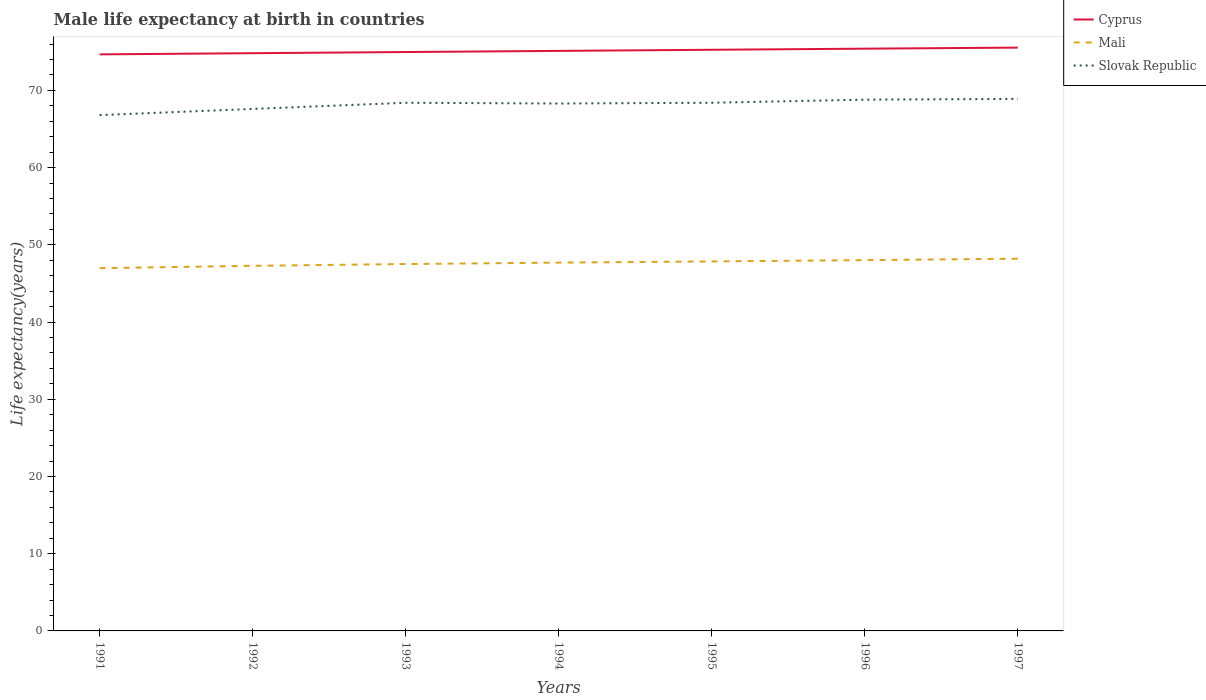Is the number of lines equal to the number of legend labels?
Provide a succinct answer. Yes. Across all years, what is the maximum male life expectancy at birth in Slovak Republic?
Your answer should be very brief. 66.8. What is the total male life expectancy at birth in Cyprus in the graph?
Ensure brevity in your answer.  -0.58. What is the difference between the highest and the lowest male life expectancy at birth in Slovak Republic?
Give a very brief answer. 5. Is the male life expectancy at birth in Slovak Republic strictly greater than the male life expectancy at birth in Mali over the years?
Offer a very short reply. No. How many lines are there?
Your answer should be very brief. 3. What is the difference between two consecutive major ticks on the Y-axis?
Your response must be concise. 10. Does the graph contain any zero values?
Ensure brevity in your answer.  No. Does the graph contain grids?
Give a very brief answer. No. How many legend labels are there?
Ensure brevity in your answer.  3. What is the title of the graph?
Give a very brief answer. Male life expectancy at birth in countries. What is the label or title of the Y-axis?
Provide a short and direct response. Life expectancy(years). What is the Life expectancy(years) in Cyprus in 1991?
Your answer should be compact. 74.67. What is the Life expectancy(years) in Mali in 1991?
Make the answer very short. 46.98. What is the Life expectancy(years) in Slovak Republic in 1991?
Ensure brevity in your answer.  66.8. What is the Life expectancy(years) of Cyprus in 1992?
Your answer should be very brief. 74.82. What is the Life expectancy(years) in Mali in 1992?
Offer a very short reply. 47.28. What is the Life expectancy(years) in Slovak Republic in 1992?
Make the answer very short. 67.6. What is the Life expectancy(years) in Cyprus in 1993?
Offer a very short reply. 74.97. What is the Life expectancy(years) in Mali in 1993?
Your response must be concise. 47.51. What is the Life expectancy(years) of Slovak Republic in 1993?
Your answer should be very brief. 68.4. What is the Life expectancy(years) of Cyprus in 1994?
Make the answer very short. 75.12. What is the Life expectancy(years) in Mali in 1994?
Provide a succinct answer. 47.7. What is the Life expectancy(years) of Slovak Republic in 1994?
Provide a short and direct response. 68.3. What is the Life expectancy(years) in Cyprus in 1995?
Your answer should be compact. 75.26. What is the Life expectancy(years) in Mali in 1995?
Your response must be concise. 47.85. What is the Life expectancy(years) of Slovak Republic in 1995?
Give a very brief answer. 68.4. What is the Life expectancy(years) in Cyprus in 1996?
Provide a short and direct response. 75.4. What is the Life expectancy(years) of Mali in 1996?
Provide a succinct answer. 48.02. What is the Life expectancy(years) in Slovak Republic in 1996?
Offer a very short reply. 68.8. What is the Life expectancy(years) of Cyprus in 1997?
Your response must be concise. 75.54. What is the Life expectancy(years) of Mali in 1997?
Your answer should be compact. 48.2. What is the Life expectancy(years) in Slovak Republic in 1997?
Your response must be concise. 68.9. Across all years, what is the maximum Life expectancy(years) of Cyprus?
Offer a terse response. 75.54. Across all years, what is the maximum Life expectancy(years) in Mali?
Your answer should be very brief. 48.2. Across all years, what is the maximum Life expectancy(years) of Slovak Republic?
Make the answer very short. 68.9. Across all years, what is the minimum Life expectancy(years) in Cyprus?
Ensure brevity in your answer.  74.67. Across all years, what is the minimum Life expectancy(years) in Mali?
Keep it short and to the point. 46.98. Across all years, what is the minimum Life expectancy(years) of Slovak Republic?
Provide a short and direct response. 66.8. What is the total Life expectancy(years) in Cyprus in the graph?
Give a very brief answer. 525.78. What is the total Life expectancy(years) of Mali in the graph?
Ensure brevity in your answer.  333.54. What is the total Life expectancy(years) in Slovak Republic in the graph?
Make the answer very short. 477.2. What is the difference between the Life expectancy(years) in Cyprus in 1991 and that in 1992?
Offer a very short reply. -0.15. What is the difference between the Life expectancy(years) in Mali in 1991 and that in 1992?
Offer a very short reply. -0.3. What is the difference between the Life expectancy(years) in Slovak Republic in 1991 and that in 1992?
Ensure brevity in your answer.  -0.8. What is the difference between the Life expectancy(years) of Cyprus in 1991 and that in 1993?
Make the answer very short. -0.3. What is the difference between the Life expectancy(years) of Mali in 1991 and that in 1993?
Offer a terse response. -0.54. What is the difference between the Life expectancy(years) of Cyprus in 1991 and that in 1994?
Keep it short and to the point. -0.45. What is the difference between the Life expectancy(years) in Mali in 1991 and that in 1994?
Provide a short and direct response. -0.72. What is the difference between the Life expectancy(years) of Cyprus in 1991 and that in 1995?
Your answer should be very brief. -0.59. What is the difference between the Life expectancy(years) of Mali in 1991 and that in 1995?
Ensure brevity in your answer.  -0.88. What is the difference between the Life expectancy(years) in Slovak Republic in 1991 and that in 1995?
Your answer should be very brief. -1.6. What is the difference between the Life expectancy(years) of Cyprus in 1991 and that in 1996?
Make the answer very short. -0.74. What is the difference between the Life expectancy(years) of Mali in 1991 and that in 1996?
Provide a succinct answer. -1.04. What is the difference between the Life expectancy(years) of Slovak Republic in 1991 and that in 1996?
Provide a short and direct response. -2. What is the difference between the Life expectancy(years) in Cyprus in 1991 and that in 1997?
Offer a terse response. -0.88. What is the difference between the Life expectancy(years) of Mali in 1991 and that in 1997?
Your answer should be compact. -1.23. What is the difference between the Life expectancy(years) of Slovak Republic in 1991 and that in 1997?
Provide a short and direct response. -2.1. What is the difference between the Life expectancy(years) of Cyprus in 1992 and that in 1993?
Keep it short and to the point. -0.15. What is the difference between the Life expectancy(years) of Mali in 1992 and that in 1993?
Make the answer very short. -0.23. What is the difference between the Life expectancy(years) in Slovak Republic in 1992 and that in 1993?
Offer a very short reply. -0.8. What is the difference between the Life expectancy(years) in Cyprus in 1992 and that in 1994?
Give a very brief answer. -0.3. What is the difference between the Life expectancy(years) of Mali in 1992 and that in 1994?
Make the answer very short. -0.41. What is the difference between the Life expectancy(years) of Slovak Republic in 1992 and that in 1994?
Make the answer very short. -0.7. What is the difference between the Life expectancy(years) of Cyprus in 1992 and that in 1995?
Provide a short and direct response. -0.44. What is the difference between the Life expectancy(years) of Mali in 1992 and that in 1995?
Your answer should be compact. -0.57. What is the difference between the Life expectancy(years) of Cyprus in 1992 and that in 1996?
Give a very brief answer. -0.58. What is the difference between the Life expectancy(years) of Mali in 1992 and that in 1996?
Your answer should be compact. -0.73. What is the difference between the Life expectancy(years) of Slovak Republic in 1992 and that in 1996?
Your response must be concise. -1.2. What is the difference between the Life expectancy(years) of Cyprus in 1992 and that in 1997?
Offer a terse response. -0.72. What is the difference between the Life expectancy(years) in Mali in 1992 and that in 1997?
Offer a terse response. -0.92. What is the difference between the Life expectancy(years) of Cyprus in 1993 and that in 1994?
Your answer should be compact. -0.15. What is the difference between the Life expectancy(years) of Mali in 1993 and that in 1994?
Give a very brief answer. -0.18. What is the difference between the Life expectancy(years) in Cyprus in 1993 and that in 1995?
Offer a very short reply. -0.29. What is the difference between the Life expectancy(years) in Mali in 1993 and that in 1995?
Your answer should be compact. -0.34. What is the difference between the Life expectancy(years) in Cyprus in 1993 and that in 1996?
Your response must be concise. -0.43. What is the difference between the Life expectancy(years) of Mali in 1993 and that in 1996?
Your answer should be compact. -0.5. What is the difference between the Life expectancy(years) of Slovak Republic in 1993 and that in 1996?
Your response must be concise. -0.4. What is the difference between the Life expectancy(years) of Cyprus in 1993 and that in 1997?
Ensure brevity in your answer.  -0.57. What is the difference between the Life expectancy(years) in Mali in 1993 and that in 1997?
Offer a terse response. -0.69. What is the difference between the Life expectancy(years) of Slovak Republic in 1993 and that in 1997?
Keep it short and to the point. -0.5. What is the difference between the Life expectancy(years) of Cyprus in 1994 and that in 1995?
Ensure brevity in your answer.  -0.14. What is the difference between the Life expectancy(years) in Mali in 1994 and that in 1995?
Give a very brief answer. -0.16. What is the difference between the Life expectancy(years) of Slovak Republic in 1994 and that in 1995?
Your answer should be very brief. -0.1. What is the difference between the Life expectancy(years) in Cyprus in 1994 and that in 1996?
Provide a short and direct response. -0.29. What is the difference between the Life expectancy(years) in Mali in 1994 and that in 1996?
Ensure brevity in your answer.  -0.32. What is the difference between the Life expectancy(years) of Cyprus in 1994 and that in 1997?
Your answer should be compact. -0.43. What is the difference between the Life expectancy(years) in Mali in 1994 and that in 1997?
Give a very brief answer. -0.51. What is the difference between the Life expectancy(years) in Slovak Republic in 1994 and that in 1997?
Keep it short and to the point. -0.6. What is the difference between the Life expectancy(years) of Cyprus in 1995 and that in 1996?
Offer a terse response. -0.14. What is the difference between the Life expectancy(years) in Mali in 1995 and that in 1996?
Make the answer very short. -0.16. What is the difference between the Life expectancy(years) of Slovak Republic in 1995 and that in 1996?
Offer a terse response. -0.4. What is the difference between the Life expectancy(years) of Cyprus in 1995 and that in 1997?
Provide a short and direct response. -0.28. What is the difference between the Life expectancy(years) of Mali in 1995 and that in 1997?
Provide a succinct answer. -0.35. What is the difference between the Life expectancy(years) in Slovak Republic in 1995 and that in 1997?
Provide a succinct answer. -0.5. What is the difference between the Life expectancy(years) of Cyprus in 1996 and that in 1997?
Your answer should be very brief. -0.14. What is the difference between the Life expectancy(years) in Mali in 1996 and that in 1997?
Offer a terse response. -0.19. What is the difference between the Life expectancy(years) in Cyprus in 1991 and the Life expectancy(years) in Mali in 1992?
Offer a very short reply. 27.39. What is the difference between the Life expectancy(years) of Cyprus in 1991 and the Life expectancy(years) of Slovak Republic in 1992?
Give a very brief answer. 7.07. What is the difference between the Life expectancy(years) of Mali in 1991 and the Life expectancy(years) of Slovak Republic in 1992?
Give a very brief answer. -20.62. What is the difference between the Life expectancy(years) in Cyprus in 1991 and the Life expectancy(years) in Mali in 1993?
Provide a short and direct response. 27.15. What is the difference between the Life expectancy(years) of Cyprus in 1991 and the Life expectancy(years) of Slovak Republic in 1993?
Offer a very short reply. 6.27. What is the difference between the Life expectancy(years) in Mali in 1991 and the Life expectancy(years) in Slovak Republic in 1993?
Offer a terse response. -21.42. What is the difference between the Life expectancy(years) of Cyprus in 1991 and the Life expectancy(years) of Mali in 1994?
Offer a very short reply. 26.97. What is the difference between the Life expectancy(years) in Cyprus in 1991 and the Life expectancy(years) in Slovak Republic in 1994?
Give a very brief answer. 6.37. What is the difference between the Life expectancy(years) in Mali in 1991 and the Life expectancy(years) in Slovak Republic in 1994?
Provide a short and direct response. -21.32. What is the difference between the Life expectancy(years) in Cyprus in 1991 and the Life expectancy(years) in Mali in 1995?
Ensure brevity in your answer.  26.81. What is the difference between the Life expectancy(years) in Cyprus in 1991 and the Life expectancy(years) in Slovak Republic in 1995?
Give a very brief answer. 6.27. What is the difference between the Life expectancy(years) of Mali in 1991 and the Life expectancy(years) of Slovak Republic in 1995?
Give a very brief answer. -21.42. What is the difference between the Life expectancy(years) in Cyprus in 1991 and the Life expectancy(years) in Mali in 1996?
Ensure brevity in your answer.  26.65. What is the difference between the Life expectancy(years) of Cyprus in 1991 and the Life expectancy(years) of Slovak Republic in 1996?
Provide a succinct answer. 5.87. What is the difference between the Life expectancy(years) of Mali in 1991 and the Life expectancy(years) of Slovak Republic in 1996?
Keep it short and to the point. -21.82. What is the difference between the Life expectancy(years) in Cyprus in 1991 and the Life expectancy(years) in Mali in 1997?
Provide a short and direct response. 26.46. What is the difference between the Life expectancy(years) in Cyprus in 1991 and the Life expectancy(years) in Slovak Republic in 1997?
Provide a short and direct response. 5.77. What is the difference between the Life expectancy(years) of Mali in 1991 and the Life expectancy(years) of Slovak Republic in 1997?
Your answer should be very brief. -21.92. What is the difference between the Life expectancy(years) in Cyprus in 1992 and the Life expectancy(years) in Mali in 1993?
Your response must be concise. 27.3. What is the difference between the Life expectancy(years) in Cyprus in 1992 and the Life expectancy(years) in Slovak Republic in 1993?
Provide a succinct answer. 6.42. What is the difference between the Life expectancy(years) of Mali in 1992 and the Life expectancy(years) of Slovak Republic in 1993?
Keep it short and to the point. -21.12. What is the difference between the Life expectancy(years) in Cyprus in 1992 and the Life expectancy(years) in Mali in 1994?
Offer a very short reply. 27.12. What is the difference between the Life expectancy(years) in Cyprus in 1992 and the Life expectancy(years) in Slovak Republic in 1994?
Give a very brief answer. 6.52. What is the difference between the Life expectancy(years) of Mali in 1992 and the Life expectancy(years) of Slovak Republic in 1994?
Your answer should be very brief. -21.02. What is the difference between the Life expectancy(years) of Cyprus in 1992 and the Life expectancy(years) of Mali in 1995?
Your answer should be compact. 26.96. What is the difference between the Life expectancy(years) of Cyprus in 1992 and the Life expectancy(years) of Slovak Republic in 1995?
Your answer should be compact. 6.42. What is the difference between the Life expectancy(years) of Mali in 1992 and the Life expectancy(years) of Slovak Republic in 1995?
Provide a short and direct response. -21.12. What is the difference between the Life expectancy(years) in Cyprus in 1992 and the Life expectancy(years) in Mali in 1996?
Provide a short and direct response. 26.8. What is the difference between the Life expectancy(years) in Cyprus in 1992 and the Life expectancy(years) in Slovak Republic in 1996?
Your answer should be very brief. 6.02. What is the difference between the Life expectancy(years) of Mali in 1992 and the Life expectancy(years) of Slovak Republic in 1996?
Your answer should be compact. -21.52. What is the difference between the Life expectancy(years) of Cyprus in 1992 and the Life expectancy(years) of Mali in 1997?
Make the answer very short. 26.61. What is the difference between the Life expectancy(years) in Cyprus in 1992 and the Life expectancy(years) in Slovak Republic in 1997?
Your response must be concise. 5.92. What is the difference between the Life expectancy(years) in Mali in 1992 and the Life expectancy(years) in Slovak Republic in 1997?
Your answer should be very brief. -21.62. What is the difference between the Life expectancy(years) of Cyprus in 1993 and the Life expectancy(years) of Mali in 1994?
Ensure brevity in your answer.  27.27. What is the difference between the Life expectancy(years) of Cyprus in 1993 and the Life expectancy(years) of Slovak Republic in 1994?
Offer a very short reply. 6.67. What is the difference between the Life expectancy(years) of Mali in 1993 and the Life expectancy(years) of Slovak Republic in 1994?
Provide a succinct answer. -20.79. What is the difference between the Life expectancy(years) in Cyprus in 1993 and the Life expectancy(years) in Mali in 1995?
Your answer should be very brief. 27.11. What is the difference between the Life expectancy(years) in Cyprus in 1993 and the Life expectancy(years) in Slovak Republic in 1995?
Your answer should be very brief. 6.57. What is the difference between the Life expectancy(years) in Mali in 1993 and the Life expectancy(years) in Slovak Republic in 1995?
Make the answer very short. -20.89. What is the difference between the Life expectancy(years) of Cyprus in 1993 and the Life expectancy(years) of Mali in 1996?
Your response must be concise. 26.95. What is the difference between the Life expectancy(years) of Cyprus in 1993 and the Life expectancy(years) of Slovak Republic in 1996?
Provide a short and direct response. 6.17. What is the difference between the Life expectancy(years) of Mali in 1993 and the Life expectancy(years) of Slovak Republic in 1996?
Ensure brevity in your answer.  -21.29. What is the difference between the Life expectancy(years) in Cyprus in 1993 and the Life expectancy(years) in Mali in 1997?
Your answer should be very brief. 26.76. What is the difference between the Life expectancy(years) of Cyprus in 1993 and the Life expectancy(years) of Slovak Republic in 1997?
Provide a short and direct response. 6.07. What is the difference between the Life expectancy(years) of Mali in 1993 and the Life expectancy(years) of Slovak Republic in 1997?
Make the answer very short. -21.39. What is the difference between the Life expectancy(years) in Cyprus in 1994 and the Life expectancy(years) in Mali in 1995?
Your answer should be very brief. 27.26. What is the difference between the Life expectancy(years) of Cyprus in 1994 and the Life expectancy(years) of Slovak Republic in 1995?
Offer a terse response. 6.72. What is the difference between the Life expectancy(years) in Mali in 1994 and the Life expectancy(years) in Slovak Republic in 1995?
Your response must be concise. -20.7. What is the difference between the Life expectancy(years) in Cyprus in 1994 and the Life expectancy(years) in Mali in 1996?
Offer a very short reply. 27.1. What is the difference between the Life expectancy(years) in Cyprus in 1994 and the Life expectancy(years) in Slovak Republic in 1996?
Ensure brevity in your answer.  6.32. What is the difference between the Life expectancy(years) of Mali in 1994 and the Life expectancy(years) of Slovak Republic in 1996?
Keep it short and to the point. -21.1. What is the difference between the Life expectancy(years) of Cyprus in 1994 and the Life expectancy(years) of Mali in 1997?
Ensure brevity in your answer.  26.91. What is the difference between the Life expectancy(years) of Cyprus in 1994 and the Life expectancy(years) of Slovak Republic in 1997?
Your answer should be compact. 6.22. What is the difference between the Life expectancy(years) in Mali in 1994 and the Life expectancy(years) in Slovak Republic in 1997?
Provide a short and direct response. -21.2. What is the difference between the Life expectancy(years) in Cyprus in 1995 and the Life expectancy(years) in Mali in 1996?
Your response must be concise. 27.25. What is the difference between the Life expectancy(years) of Cyprus in 1995 and the Life expectancy(years) of Slovak Republic in 1996?
Your response must be concise. 6.46. What is the difference between the Life expectancy(years) of Mali in 1995 and the Life expectancy(years) of Slovak Republic in 1996?
Provide a succinct answer. -20.95. What is the difference between the Life expectancy(years) of Cyprus in 1995 and the Life expectancy(years) of Mali in 1997?
Make the answer very short. 27.06. What is the difference between the Life expectancy(years) in Cyprus in 1995 and the Life expectancy(years) in Slovak Republic in 1997?
Your answer should be very brief. 6.36. What is the difference between the Life expectancy(years) of Mali in 1995 and the Life expectancy(years) of Slovak Republic in 1997?
Give a very brief answer. -21.05. What is the difference between the Life expectancy(years) in Cyprus in 1996 and the Life expectancy(years) in Mali in 1997?
Your answer should be compact. 27.2. What is the difference between the Life expectancy(years) in Cyprus in 1996 and the Life expectancy(years) in Slovak Republic in 1997?
Keep it short and to the point. 6.5. What is the difference between the Life expectancy(years) of Mali in 1996 and the Life expectancy(years) of Slovak Republic in 1997?
Provide a short and direct response. -20.88. What is the average Life expectancy(years) of Cyprus per year?
Your answer should be compact. 75.11. What is the average Life expectancy(years) of Mali per year?
Offer a terse response. 47.65. What is the average Life expectancy(years) in Slovak Republic per year?
Your answer should be compact. 68.17. In the year 1991, what is the difference between the Life expectancy(years) of Cyprus and Life expectancy(years) of Mali?
Your response must be concise. 27.69. In the year 1991, what is the difference between the Life expectancy(years) in Cyprus and Life expectancy(years) in Slovak Republic?
Give a very brief answer. 7.87. In the year 1991, what is the difference between the Life expectancy(years) of Mali and Life expectancy(years) of Slovak Republic?
Make the answer very short. -19.82. In the year 1992, what is the difference between the Life expectancy(years) in Cyprus and Life expectancy(years) in Mali?
Your response must be concise. 27.54. In the year 1992, what is the difference between the Life expectancy(years) in Cyprus and Life expectancy(years) in Slovak Republic?
Your response must be concise. 7.22. In the year 1992, what is the difference between the Life expectancy(years) in Mali and Life expectancy(years) in Slovak Republic?
Give a very brief answer. -20.32. In the year 1993, what is the difference between the Life expectancy(years) of Cyprus and Life expectancy(years) of Mali?
Provide a succinct answer. 27.45. In the year 1993, what is the difference between the Life expectancy(years) of Cyprus and Life expectancy(years) of Slovak Republic?
Offer a terse response. 6.57. In the year 1993, what is the difference between the Life expectancy(years) of Mali and Life expectancy(years) of Slovak Republic?
Ensure brevity in your answer.  -20.89. In the year 1994, what is the difference between the Life expectancy(years) in Cyprus and Life expectancy(years) in Mali?
Keep it short and to the point. 27.42. In the year 1994, what is the difference between the Life expectancy(years) of Cyprus and Life expectancy(years) of Slovak Republic?
Make the answer very short. 6.82. In the year 1994, what is the difference between the Life expectancy(years) in Mali and Life expectancy(years) in Slovak Republic?
Keep it short and to the point. -20.6. In the year 1995, what is the difference between the Life expectancy(years) in Cyprus and Life expectancy(years) in Mali?
Offer a very short reply. 27.41. In the year 1995, what is the difference between the Life expectancy(years) in Cyprus and Life expectancy(years) in Slovak Republic?
Your answer should be compact. 6.86. In the year 1995, what is the difference between the Life expectancy(years) in Mali and Life expectancy(years) in Slovak Republic?
Your answer should be very brief. -20.55. In the year 1996, what is the difference between the Life expectancy(years) in Cyprus and Life expectancy(years) in Mali?
Offer a terse response. 27.39. In the year 1996, what is the difference between the Life expectancy(years) of Cyprus and Life expectancy(years) of Slovak Republic?
Keep it short and to the point. 6.6. In the year 1996, what is the difference between the Life expectancy(years) of Mali and Life expectancy(years) of Slovak Republic?
Your answer should be very brief. -20.78. In the year 1997, what is the difference between the Life expectancy(years) in Cyprus and Life expectancy(years) in Mali?
Offer a terse response. 27.34. In the year 1997, what is the difference between the Life expectancy(years) of Cyprus and Life expectancy(years) of Slovak Republic?
Your answer should be very brief. 6.64. In the year 1997, what is the difference between the Life expectancy(years) in Mali and Life expectancy(years) in Slovak Republic?
Keep it short and to the point. -20.7. What is the ratio of the Life expectancy(years) in Cyprus in 1991 to that in 1992?
Make the answer very short. 1. What is the ratio of the Life expectancy(years) of Mali in 1991 to that in 1992?
Ensure brevity in your answer.  0.99. What is the ratio of the Life expectancy(years) of Slovak Republic in 1991 to that in 1992?
Your answer should be compact. 0.99. What is the ratio of the Life expectancy(years) in Mali in 1991 to that in 1993?
Keep it short and to the point. 0.99. What is the ratio of the Life expectancy(years) of Slovak Republic in 1991 to that in 1993?
Your response must be concise. 0.98. What is the ratio of the Life expectancy(years) in Cyprus in 1991 to that in 1994?
Offer a terse response. 0.99. What is the ratio of the Life expectancy(years) in Mali in 1991 to that in 1994?
Your answer should be compact. 0.98. What is the ratio of the Life expectancy(years) of Mali in 1991 to that in 1995?
Make the answer very short. 0.98. What is the ratio of the Life expectancy(years) of Slovak Republic in 1991 to that in 1995?
Your answer should be very brief. 0.98. What is the ratio of the Life expectancy(years) of Cyprus in 1991 to that in 1996?
Your response must be concise. 0.99. What is the ratio of the Life expectancy(years) of Mali in 1991 to that in 1996?
Provide a short and direct response. 0.98. What is the ratio of the Life expectancy(years) of Slovak Republic in 1991 to that in 1996?
Give a very brief answer. 0.97. What is the ratio of the Life expectancy(years) in Cyprus in 1991 to that in 1997?
Provide a succinct answer. 0.99. What is the ratio of the Life expectancy(years) in Mali in 1991 to that in 1997?
Offer a very short reply. 0.97. What is the ratio of the Life expectancy(years) in Slovak Republic in 1991 to that in 1997?
Your answer should be very brief. 0.97. What is the ratio of the Life expectancy(years) of Slovak Republic in 1992 to that in 1993?
Provide a succinct answer. 0.99. What is the ratio of the Life expectancy(years) of Cyprus in 1992 to that in 1994?
Give a very brief answer. 1. What is the ratio of the Life expectancy(years) in Mali in 1992 to that in 1994?
Your answer should be compact. 0.99. What is the ratio of the Life expectancy(years) in Slovak Republic in 1992 to that in 1994?
Your answer should be very brief. 0.99. What is the ratio of the Life expectancy(years) in Mali in 1992 to that in 1995?
Make the answer very short. 0.99. What is the ratio of the Life expectancy(years) in Slovak Republic in 1992 to that in 1995?
Ensure brevity in your answer.  0.99. What is the ratio of the Life expectancy(years) in Cyprus in 1992 to that in 1996?
Your answer should be compact. 0.99. What is the ratio of the Life expectancy(years) of Mali in 1992 to that in 1996?
Your answer should be very brief. 0.98. What is the ratio of the Life expectancy(years) of Slovak Republic in 1992 to that in 1996?
Provide a short and direct response. 0.98. What is the ratio of the Life expectancy(years) in Mali in 1992 to that in 1997?
Make the answer very short. 0.98. What is the ratio of the Life expectancy(years) of Slovak Republic in 1992 to that in 1997?
Provide a succinct answer. 0.98. What is the ratio of the Life expectancy(years) of Mali in 1993 to that in 1995?
Offer a very short reply. 0.99. What is the ratio of the Life expectancy(years) of Cyprus in 1993 to that in 1996?
Your response must be concise. 0.99. What is the ratio of the Life expectancy(years) of Mali in 1993 to that in 1997?
Make the answer very short. 0.99. What is the ratio of the Life expectancy(years) of Cyprus in 1994 to that in 1995?
Your response must be concise. 1. What is the ratio of the Life expectancy(years) in Mali in 1994 to that in 1995?
Your response must be concise. 1. What is the ratio of the Life expectancy(years) in Slovak Republic in 1994 to that in 1995?
Your response must be concise. 1. What is the ratio of the Life expectancy(years) in Slovak Republic in 1994 to that in 1996?
Your answer should be very brief. 0.99. What is the ratio of the Life expectancy(years) of Mali in 1995 to that in 1996?
Ensure brevity in your answer.  1. What is the ratio of the Life expectancy(years) of Cyprus in 1995 to that in 1997?
Keep it short and to the point. 1. What is the ratio of the Life expectancy(years) of Mali in 1995 to that in 1997?
Make the answer very short. 0.99. What is the difference between the highest and the second highest Life expectancy(years) in Cyprus?
Keep it short and to the point. 0.14. What is the difference between the highest and the second highest Life expectancy(years) in Mali?
Offer a very short reply. 0.19. What is the difference between the highest and the lowest Life expectancy(years) in Mali?
Provide a succinct answer. 1.23. What is the difference between the highest and the lowest Life expectancy(years) of Slovak Republic?
Make the answer very short. 2.1. 